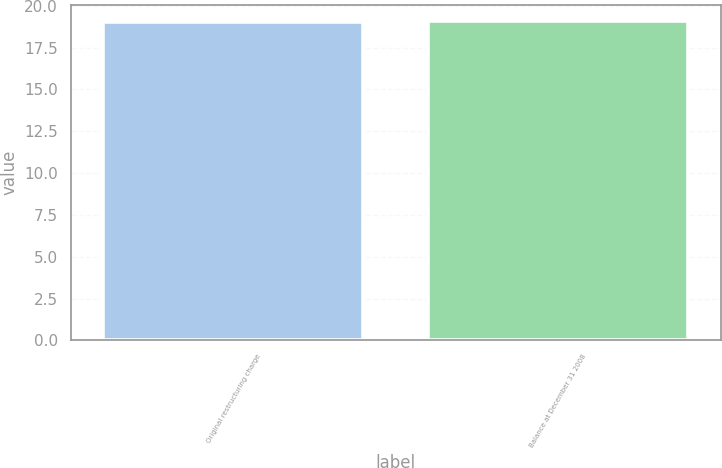Convert chart. <chart><loc_0><loc_0><loc_500><loc_500><bar_chart><fcel>Original restructuring charge<fcel>Balance at December 31 2008<nl><fcel>19<fcel>19.1<nl></chart> 